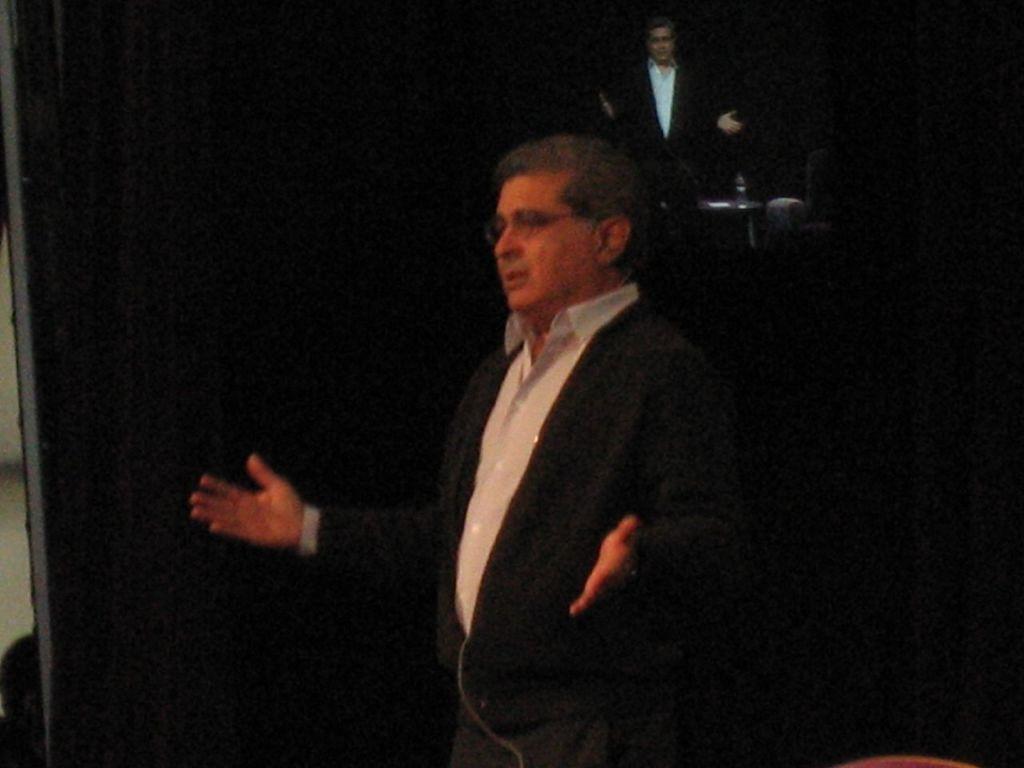In one or two sentences, can you explain what this image depicts? In this image I can see the dark picture in which I can see a person standing. I can see the black colored background in which I can see a person. 